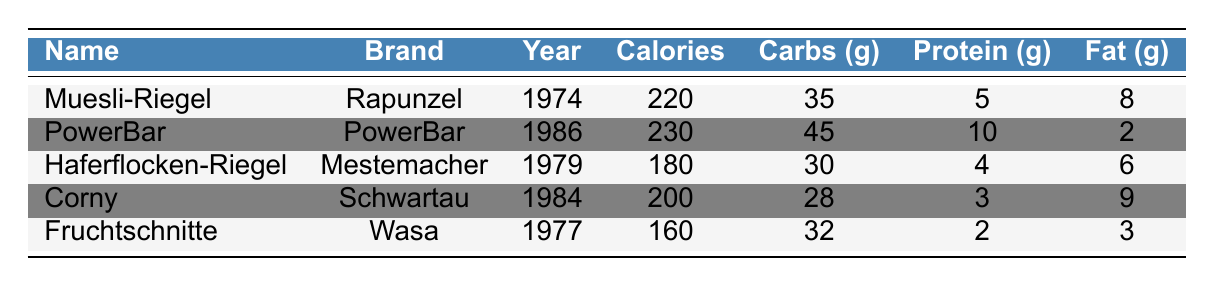What is the calorie content of the PowerBar? The table lists PowerBar under the energy bars, and its corresponding calorie content is shown in the "Calories" column, which states 230 calories.
Answer: 230 Which energy bar has the highest protein content? By examining the "Protein (g)" column, PowerBar has the highest value at 10 grams, compared to the others which range from 2 to 5 grams.
Answer: PowerBar What is the average calorie content of the energy bars? First, add the calorie values: 220 + 230 + 180 + 200 + 160 = 1090. Next, divide by the number of bars (5): 1090/5 = 218.
Answer: 218 Did Fruchtschnitte have more fat content than Haferflocken-Riegel? Comparing the "Fat (g)" column, Fruchtschnitte has 3 grams and Haferflocken-Riegel has 6 grams. Since 3 is less than 6, the statement is false.
Answer: No How many grams of carbohydrates are there in total across all energy bars? To find the total, sum the carbohydrate values: 35 + 45 + 30 + 28 + 32 = 170.
Answer: 170 Which energy bar was introduced first? Looking at the "Year" column, Muesli-Riegel is listed as the first at 1974.
Answer: Muesli-Riegel Is there an energy bar that contains more fiber than Corny? Corny has 2 grams of fiber according to the "Fiber" column, while Fruchtschnitte has 5 grams, which is more. Thus, the statement is true.
Answer: Yes What is the difference in fat content between the highest and lowest among the energy bars? The highest fat content is in Corny at 9 grams, and the lowest is in PowerBar at 2 grams. The difference is 9 - 2 = 7 grams.
Answer: 7 Which brand has the most energy bars listed? Each brand has only one energy bar listed in this table. Therefore, no brand has more than one.
Answer: None What is the fiber content of Haferflocken-Riegel? Haferflocken-Riegel's fiber content is displayed as 4 grams in the "Fiber" column.
Answer: 4 